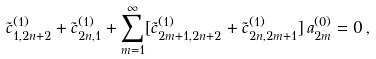Convert formula to latex. <formula><loc_0><loc_0><loc_500><loc_500>\tilde { c } _ { 1 , 2 n + 2 } ^ { ( 1 ) } + \tilde { c } _ { 2 n , 1 } ^ { ( 1 ) } + \sum _ { m = 1 } ^ { \infty } [ \tilde { c } _ { 2 m + 1 , 2 n + 2 } ^ { ( 1 ) } + \tilde { c } _ { 2 n , 2 m + 1 } ^ { ( 1 ) } ] \, a _ { 2 m } ^ { ( 0 ) } = 0 \, ,</formula> 